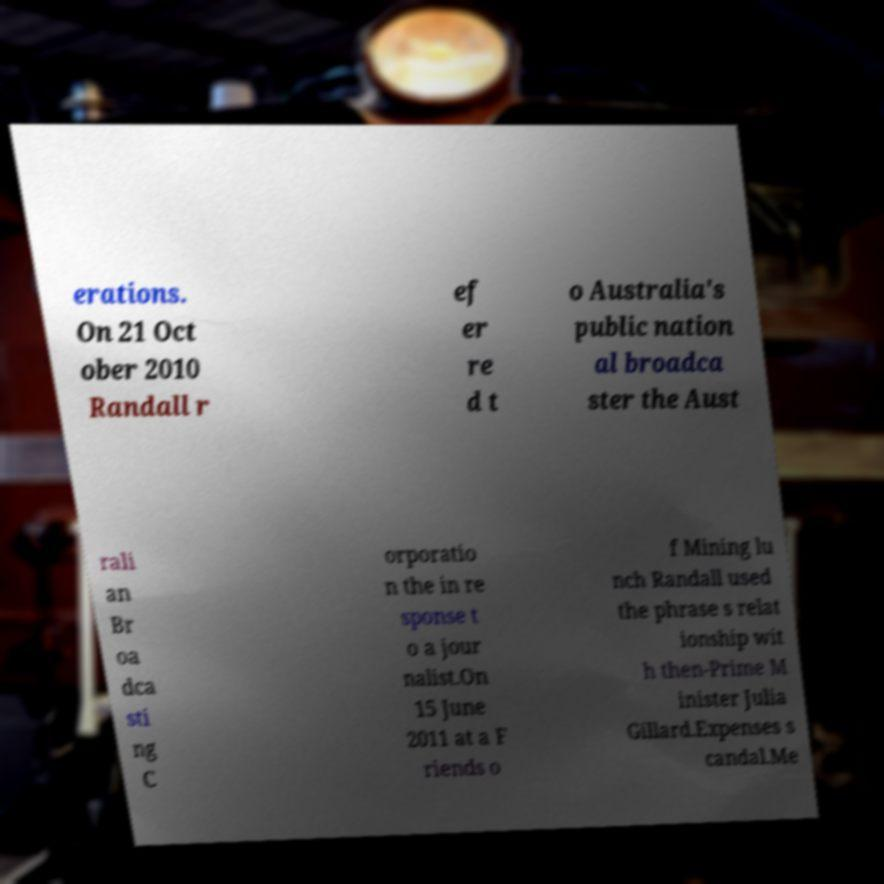For documentation purposes, I need the text within this image transcribed. Could you provide that? erations. On 21 Oct ober 2010 Randall r ef er re d t o Australia's public nation al broadca ster the Aust rali an Br oa dca sti ng C orporatio n the in re sponse t o a jour nalist.On 15 June 2011 at a F riends o f Mining lu nch Randall used the phrase s relat ionship wit h then-Prime M inister Julia Gillard.Expenses s candal.Me 